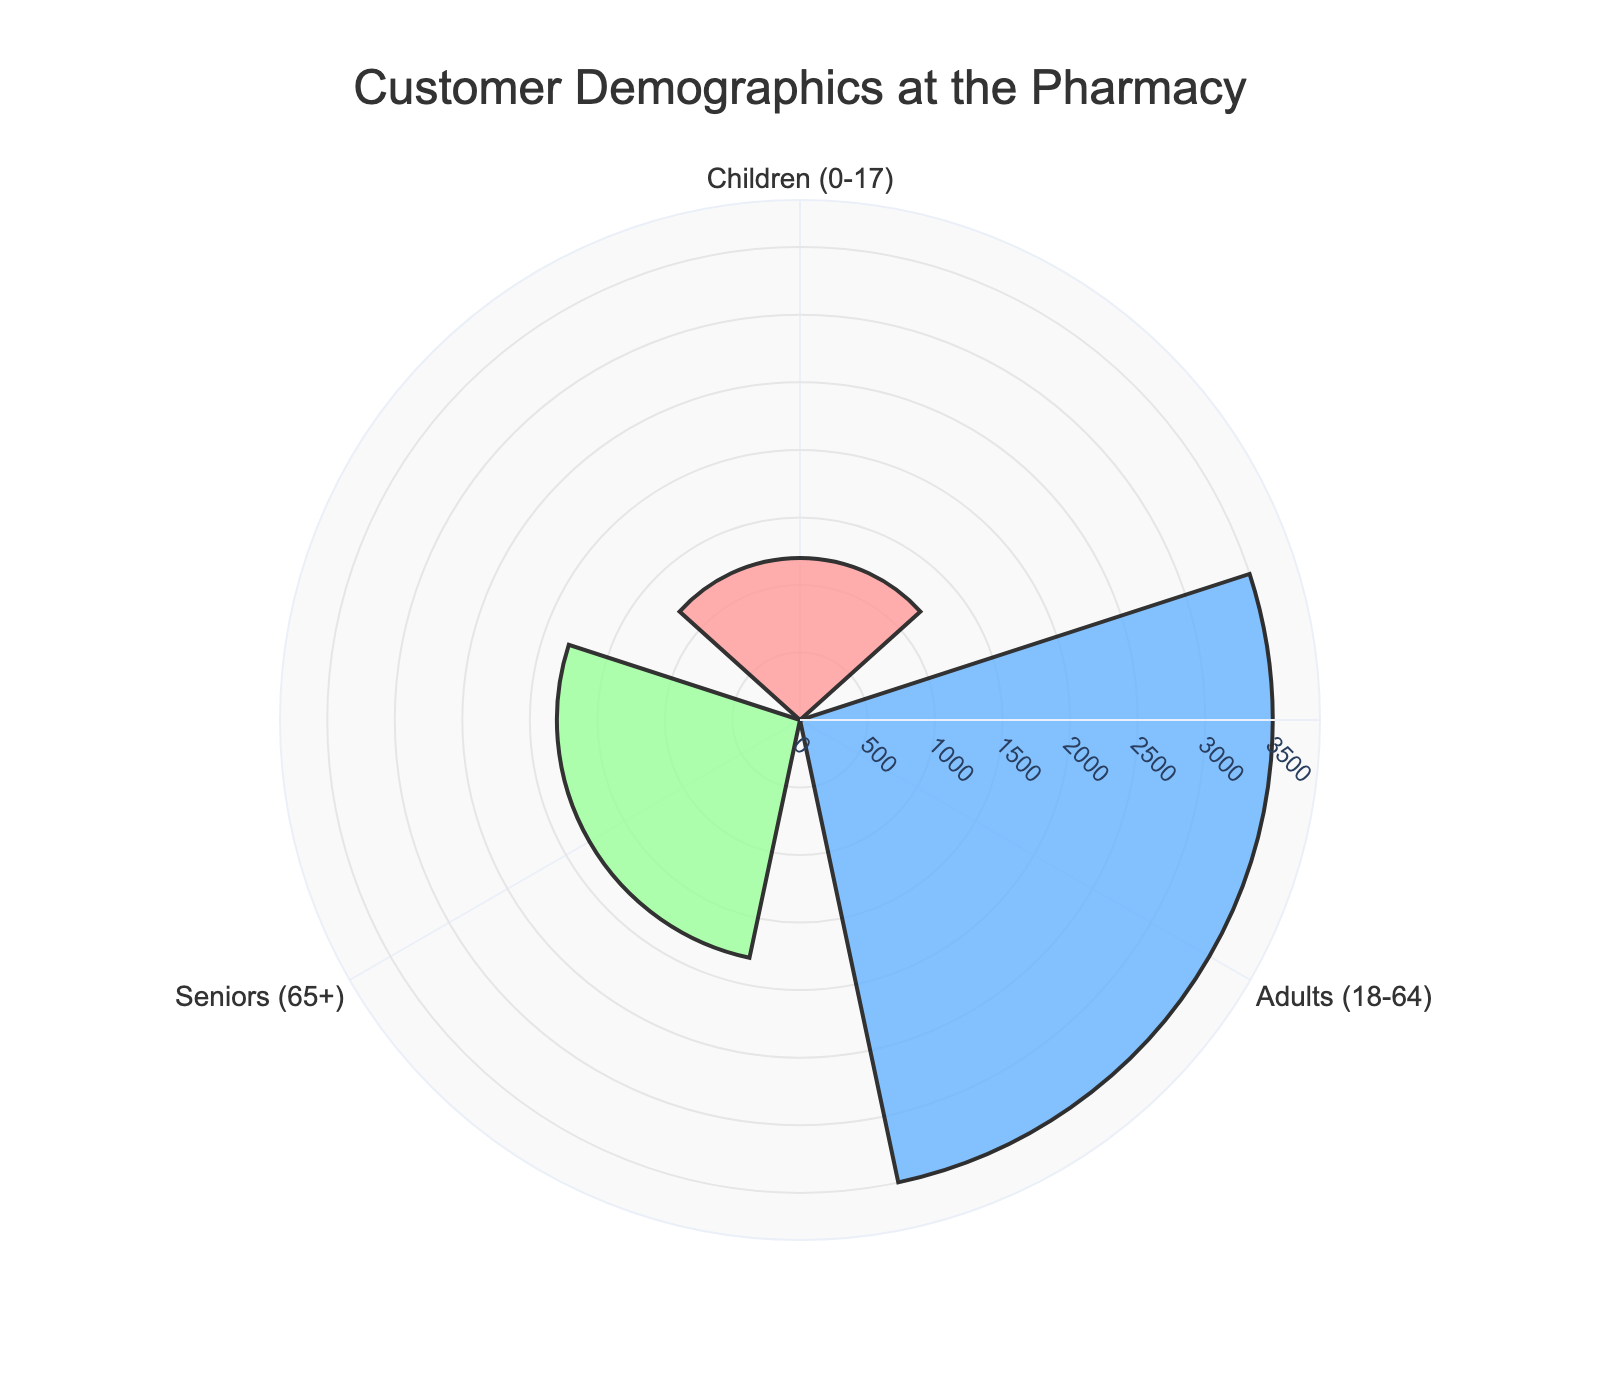which age group has the highest customer count? The figure shows three age groups: Children, Adults, and Seniors. By visually inspecting the lengths of the bars in the rose chart, Adults have the longest bar, indicating they have the highest count.
Answer: Adults which color represents the Children age group? The figure uses different colors for each age group. By matching the start position of the colors with the age groups, the outermost bar (representing Children) is colored pink.
Answer: Pink what is the total number of customers across all age groups? Add the counts for Children (1200), Adults (3500), and Seniors (1800) to get the total number of customers: 1200 + 3500 + 1800 = 6500
Answer: 6500 how much greater is the count of adults compared to seniors? The count for Adults is 3500 and for Seniors is 1800. Subtract the count of Seniors from Adults: 3500 - 1800 = 1700
Answer: 1700 which age group makes up the smallest segment of customers? By comparing the lengths of the bars directly, the bar for Children is the shortest, indicating this age group has the smallest count.
Answer: Children what is the average number of customers across the three age groups? Sum the counts for all age groups: 1200 (Children) + 3500 (Adults) + 1800 (Seniors) = 6500. Then, divide by the number of groups: 6500 / 3 ≈ 2167
Answer: 2167 if you combine the counts of children and seniors, does it exceed adults? Combine the counts of Children and Seniors: 1200 + 1800 = 3000. Compare this sum to the count of Adults (3500). Since 3000 is less than 3500, it does not exceed the count of Adults.
Answer: No what percentage of the total customers does the children age group represent? The count for Children is 1200 and the total number of customers is 6500. Divide the count of Children by the total and multiply by 100: (1200 / 6500) * 100 ≈ 18.46%
Answer: 18.46% how does the number of children compare to the average number of customers? The average number of customers is 2167, and the count for Children is 1200. Since 1200 is less than 2167, the number of children is below the average.
Answer: Below which age group is colored green? The figure uses different colors for each age group. By visually matching the colors to the age groups, the innermost bar (representing Seniors) is colored green.
Answer: Seniors 